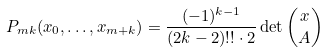Convert formula to latex. <formula><loc_0><loc_0><loc_500><loc_500>P _ { m k } ( x _ { 0 } , \dots , x _ { m + k } ) = \frac { ( - 1 ) ^ { k - 1 } } { ( 2 k - 2 ) ! ! \cdot 2 } \det \binom { x } { A }</formula> 